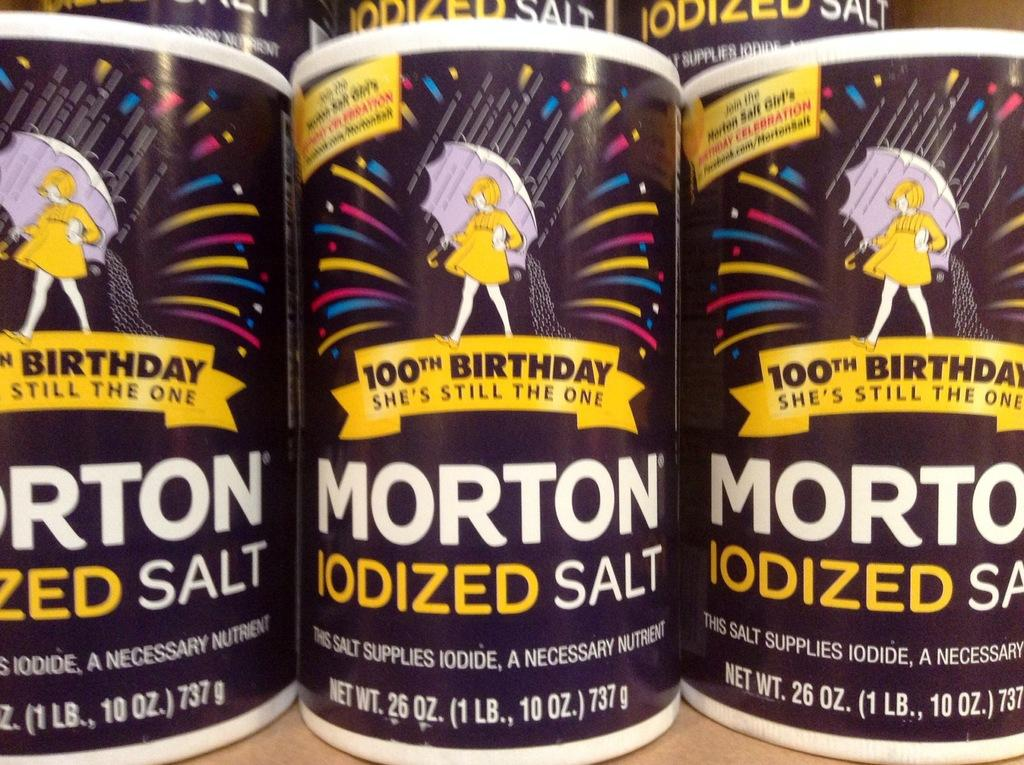What objects are present in the image? There are boxes in the image. What can be seen on the boxes? There is writing on the boxes. What color are the boxes? The boxes are purple in color. What is the color of the surface the boxes are on? The boxes are on a cream-colored surface. How many dogs are sitting on the boxes in the image? There are no dogs present in the image; it only features boxes with writing on them. 